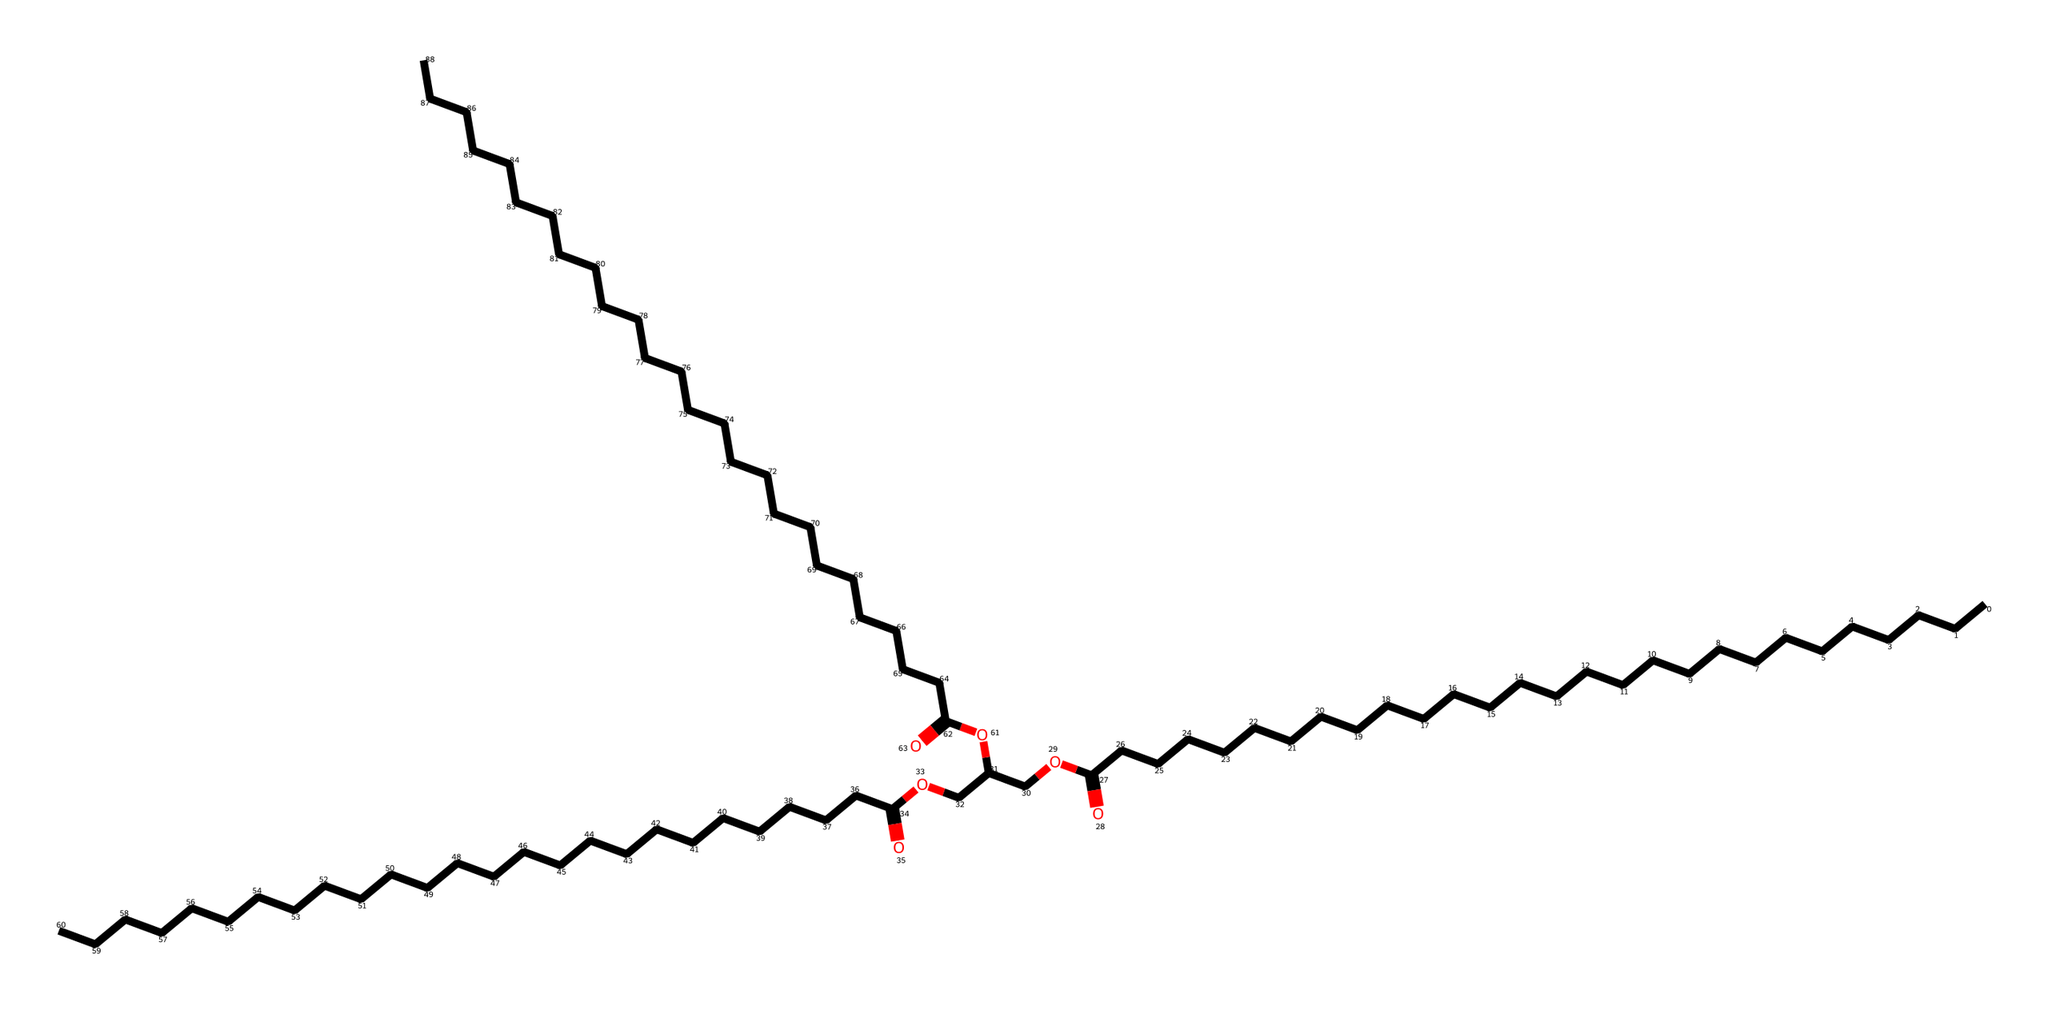What is the molecular formula of this chemical? The chemical structure can be analyzed by counting the number of carbon (C), hydrogen (H), and oxygen (O) atoms present. In this structure, there are 58 carbon atoms, 112 hydrogen atoms, and 6 oxygen atoms. Therefore, the molecular formula is C58H112O6.
Answer: C58H112O6 How many functional groups are present in this molecule? By examining the chemical structure, we can identify several functional groups: there are ester groups (–COOC) and a carboxylic acid group (–COOH). Counting these, the molecule contains a total of 5 functional groups.
Answer: 5 What types of bonds are predominant in this chemical? The majority of bonds in this chemical structure are single (C–C and C–H) and some carbon-oxygen (C–O) bonds. These are primarily single bonds, with one double bond in the carboxylic acid group (C=O). Therefore, the predominant types of bonds are single bonds.
Answer: Single bonds What property gives beeswax its lubrication ability? The long hydrocarbon chains in the chemical structure provide a non-polar environment, which allows the substance to reduce friction and enhance lubrication. This property is a result of the molecular composition and the presence of ester functional groups.
Answer: Non-polar environment How does the chain length affect the melting point of beeswax? The melting point of beeswax is influenced by the length of the carbon chains; longer chains achieve higher molecular weight, which typically leads to increased interactions between molecules and a higher melting point. Thus, the larger the number of carbon atoms, the higher the melting point.
Answer: Higher melting point What role do the ester groups play in the use of beeswax for furniture polish? Ester groups contribute to the smooth texture and moisture-retaining properties of beeswax, which makes it effective in preventing wood from drying out, enhancing the shine while providing a protective layer. This is crucial in furniture polish.
Answer: Moisture-retaining properties 